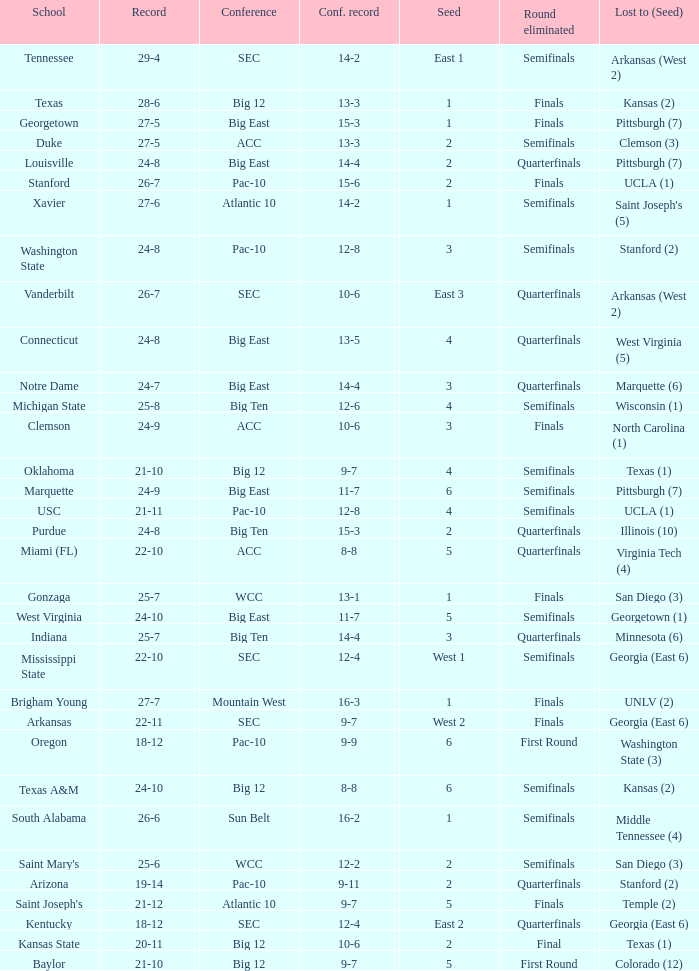Name the round eliminated where conference record is 12-6 Semifinals. 